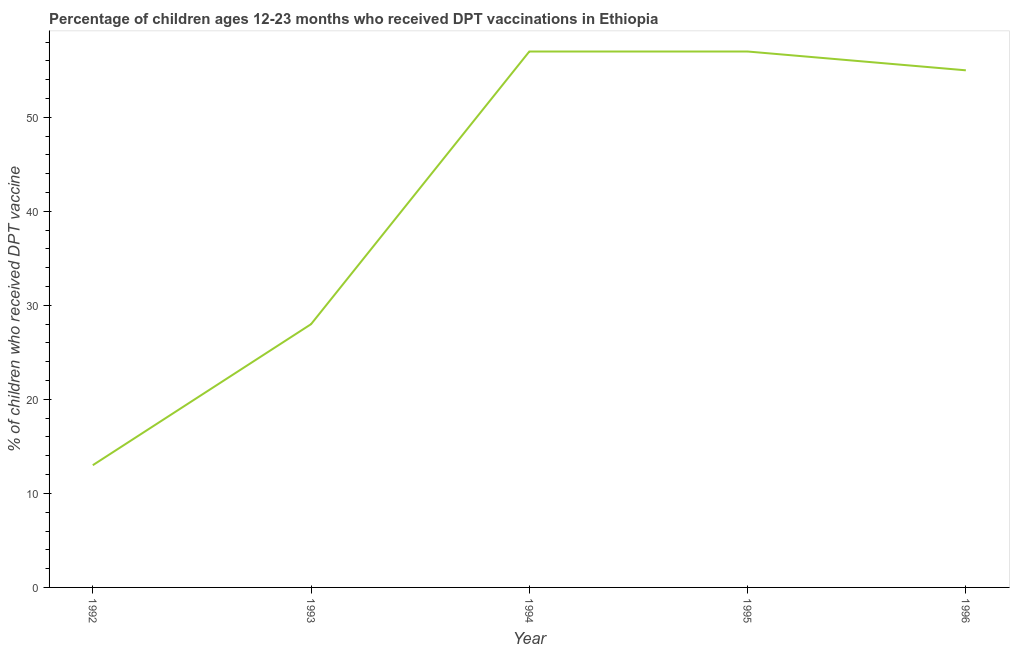What is the percentage of children who received dpt vaccine in 1995?
Your answer should be compact. 57. Across all years, what is the maximum percentage of children who received dpt vaccine?
Provide a succinct answer. 57. Across all years, what is the minimum percentage of children who received dpt vaccine?
Your response must be concise. 13. In which year was the percentage of children who received dpt vaccine maximum?
Make the answer very short. 1994. What is the sum of the percentage of children who received dpt vaccine?
Ensure brevity in your answer.  210. What is the difference between the percentage of children who received dpt vaccine in 1993 and 1996?
Provide a short and direct response. -27. What is the median percentage of children who received dpt vaccine?
Provide a short and direct response. 55. What is the ratio of the percentage of children who received dpt vaccine in 1995 to that in 1996?
Your answer should be compact. 1.04. Is the difference between the percentage of children who received dpt vaccine in 1992 and 1994 greater than the difference between any two years?
Offer a terse response. Yes. What is the difference between the highest and the second highest percentage of children who received dpt vaccine?
Make the answer very short. 0. Is the sum of the percentage of children who received dpt vaccine in 1993 and 1995 greater than the maximum percentage of children who received dpt vaccine across all years?
Give a very brief answer. Yes. What is the difference between the highest and the lowest percentage of children who received dpt vaccine?
Your response must be concise. 44. In how many years, is the percentage of children who received dpt vaccine greater than the average percentage of children who received dpt vaccine taken over all years?
Your response must be concise. 3. Does the percentage of children who received dpt vaccine monotonically increase over the years?
Your response must be concise. No. What is the difference between two consecutive major ticks on the Y-axis?
Keep it short and to the point. 10. Are the values on the major ticks of Y-axis written in scientific E-notation?
Your answer should be very brief. No. Does the graph contain any zero values?
Give a very brief answer. No. What is the title of the graph?
Provide a succinct answer. Percentage of children ages 12-23 months who received DPT vaccinations in Ethiopia. What is the label or title of the Y-axis?
Provide a short and direct response. % of children who received DPT vaccine. What is the difference between the % of children who received DPT vaccine in 1992 and 1994?
Keep it short and to the point. -44. What is the difference between the % of children who received DPT vaccine in 1992 and 1995?
Ensure brevity in your answer.  -44. What is the difference between the % of children who received DPT vaccine in 1992 and 1996?
Make the answer very short. -42. What is the difference between the % of children who received DPT vaccine in 1993 and 1994?
Offer a terse response. -29. What is the difference between the % of children who received DPT vaccine in 1993 and 1995?
Keep it short and to the point. -29. What is the difference between the % of children who received DPT vaccine in 1993 and 1996?
Provide a short and direct response. -27. What is the difference between the % of children who received DPT vaccine in 1995 and 1996?
Keep it short and to the point. 2. What is the ratio of the % of children who received DPT vaccine in 1992 to that in 1993?
Offer a terse response. 0.46. What is the ratio of the % of children who received DPT vaccine in 1992 to that in 1994?
Ensure brevity in your answer.  0.23. What is the ratio of the % of children who received DPT vaccine in 1992 to that in 1995?
Make the answer very short. 0.23. What is the ratio of the % of children who received DPT vaccine in 1992 to that in 1996?
Give a very brief answer. 0.24. What is the ratio of the % of children who received DPT vaccine in 1993 to that in 1994?
Offer a very short reply. 0.49. What is the ratio of the % of children who received DPT vaccine in 1993 to that in 1995?
Offer a very short reply. 0.49. What is the ratio of the % of children who received DPT vaccine in 1993 to that in 1996?
Ensure brevity in your answer.  0.51. What is the ratio of the % of children who received DPT vaccine in 1994 to that in 1996?
Offer a terse response. 1.04. What is the ratio of the % of children who received DPT vaccine in 1995 to that in 1996?
Provide a succinct answer. 1.04. 